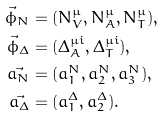<formula> <loc_0><loc_0><loc_500><loc_500>\vec { \phi } _ { N } & = ( N _ { V } ^ { \mu } , N _ { A } ^ { \mu } , N _ { T } ^ { \mu } ) , \\ \vec { \phi } _ { \Delta } & = ( \Delta _ { A } ^ { \mu i } , \Delta _ { T } ^ { \mu i } ) , \\ \vec { a _ { N } } & = ( a _ { 1 } ^ { N } , a _ { 2 } ^ { N } , a _ { 3 } ^ { N } ) , \\ \vec { a _ { \Delta } } & = ( a _ { 1 } ^ { \Delta } , a _ { 2 } ^ { \Delta } ) .</formula> 